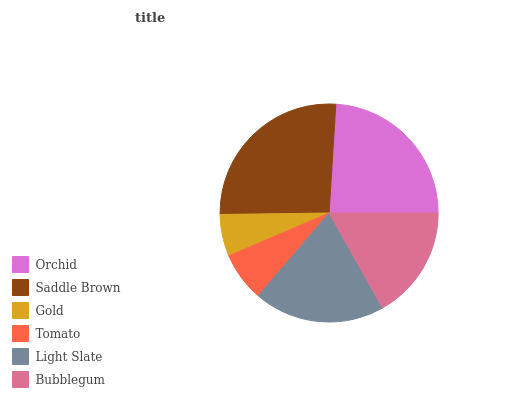Is Gold the minimum?
Answer yes or no. Yes. Is Saddle Brown the maximum?
Answer yes or no. Yes. Is Saddle Brown the minimum?
Answer yes or no. No. Is Gold the maximum?
Answer yes or no. No. Is Saddle Brown greater than Gold?
Answer yes or no. Yes. Is Gold less than Saddle Brown?
Answer yes or no. Yes. Is Gold greater than Saddle Brown?
Answer yes or no. No. Is Saddle Brown less than Gold?
Answer yes or no. No. Is Light Slate the high median?
Answer yes or no. Yes. Is Bubblegum the low median?
Answer yes or no. Yes. Is Saddle Brown the high median?
Answer yes or no. No. Is Saddle Brown the low median?
Answer yes or no. No. 